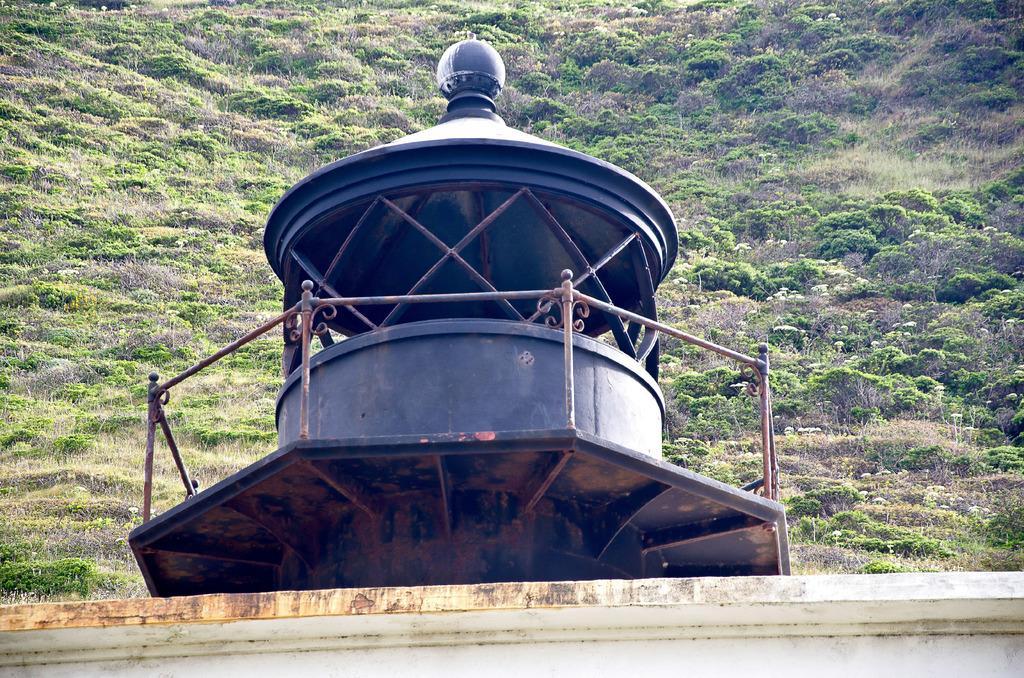How would you summarize this image in a sentence or two? In this image, we can see a shelter, rod railing, wall. Background we can see plants. 